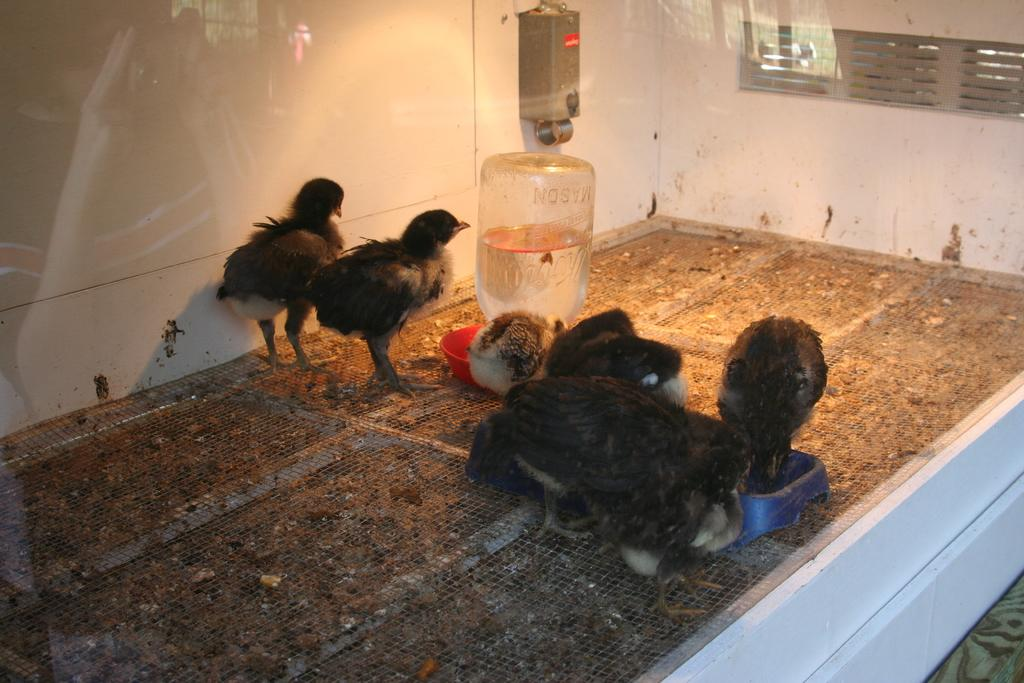What is located in the center of the image? There are birds and a water bottle in the center of the image. What type of enclosure is depicted in the image? The image appears to depict a glass cage. How many times did the bird kick the ring in the image? There is no ring present in the image, and birds do not have the ability to kick. 